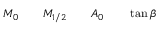<formula> <loc_0><loc_0><loc_500><loc_500>M _ { 0 } \quad M _ { 1 / 2 } \quad A _ { 0 } \quad \tan \beta</formula> 